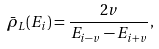Convert formula to latex. <formula><loc_0><loc_0><loc_500><loc_500>\bar { \rho } _ { L } ( E _ { i } ) = \frac { 2 v } { E _ { i - v } - E _ { i + v } } ,</formula> 